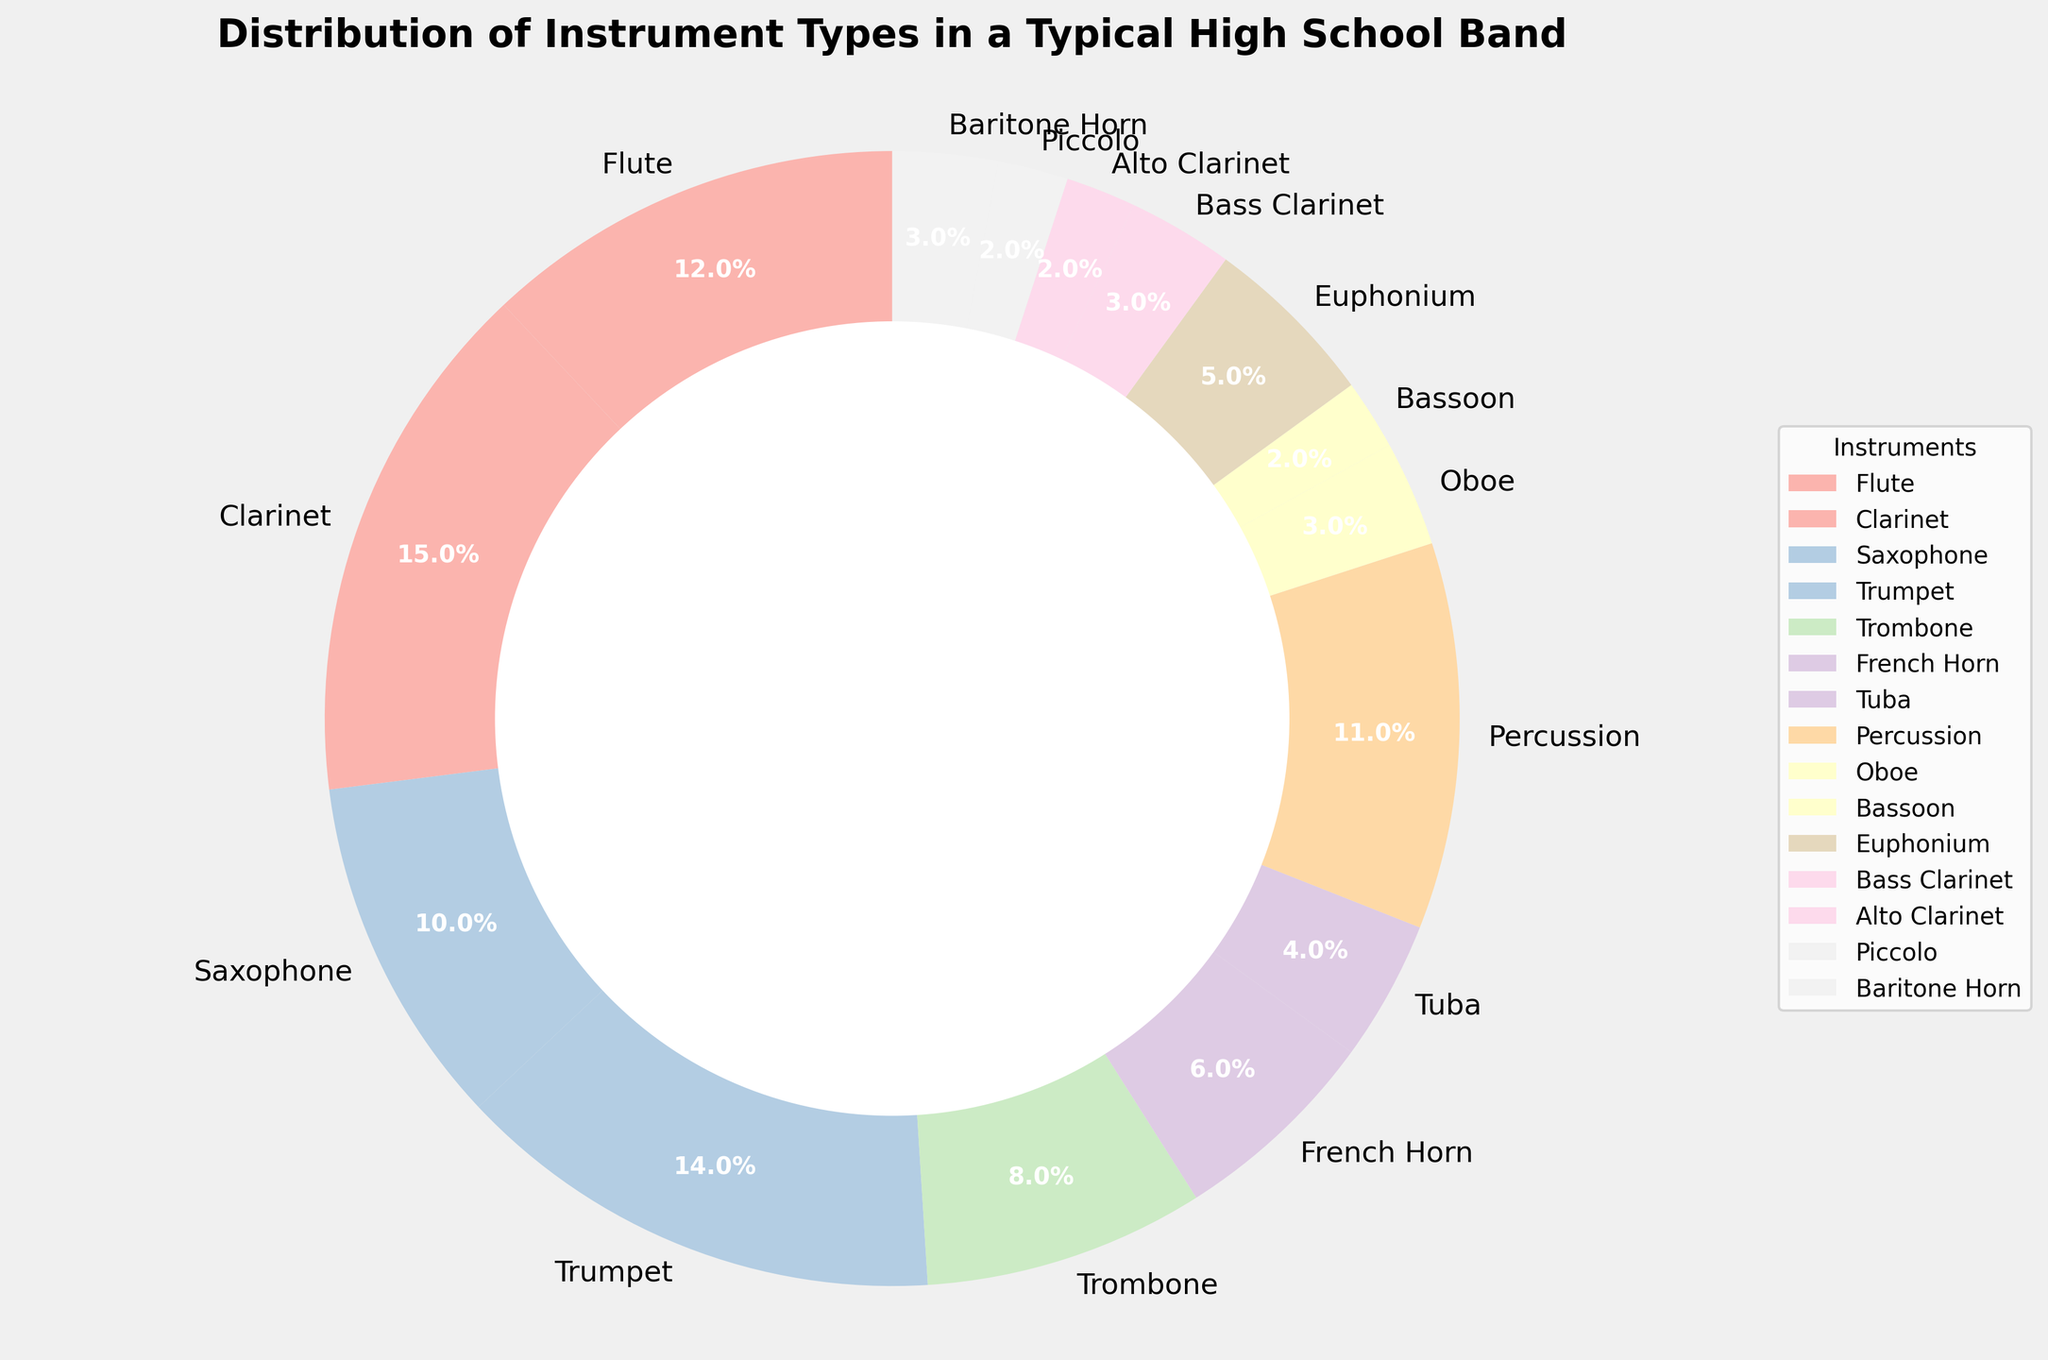What is the largest represented instrument in the band? By observing the chart, the Clarinet has the largest slice at 15%.
Answer: Clarinet What is the total percentage of woodwind instruments (Flute, Clarinet, Saxophone, Oboe, Bassoon, Bass Clarinet, Alto Clarinet, Piccolo)? Adding up the percentages: Flute (12) + Clarinet (15) + Saxophone (10) + Oboe (3) + Bassoon (2) + Bass Clarinet (3) + Alto Clarinet (2) + Piccolo (2) = 49%
Answer: 49% Which instrument group is larger: Brass or Percussion? Brass consists of Trumpet (14) + Trombone (8) + French Horn (6) + Tuba (4) + Euphonium (5) + Baritone Horn (3) = 40%. Percussion is 11%. Therefore, Brass is larger.
Answer: Brass How many instruments have a representation of 4% or less? Instruments with 4% or less are Tuba (4), Oboe (3), Bassoon (2), Bass Clarinet (3), Alto Clarinet (2), Piccolo (2), Baritone Horn (3). There are 7 such instruments in total.
Answer: 7 What is the combined percentage of the least represented instruments (Bassoon, Alto Clarinet, and Piccolo)? Adding up the percentages: Bassoon (2) + Alto Clarinet (2) + Piccolo (2) = 6%
Answer: 6% Which is more common: Flute or Trumpet? By observing the chart, Flute has a percentage of 12%, and Trumpet has a percentage of 14%. Thus, Trumpet is more common.
Answer: Trumpet What is the difference in percentage between the highest (Clarinet) and the lowest (Bassoon) represented instruments? The highest representation is Clarinet at 15% and the lowest is Bassoon at 2%. The difference is 15 - 2 = 13%.
Answer: 13% What is the second most represented instrument type? The second largest slice belongs to the Flute at 12%.
Answer: Flute Compare the combined percentage of Oboe and Bassoon to that of Euphonium. Which is larger? Oboe (3) + Bassoon (2) = 5%. Euphonium alone is also 5%. Thus, they are equal.
Answer: Equal Which instrument has a similar representation to the Percussion section? Percussion is represented by 11%. The closest instrument to this percentage is Saxophone at 10%.
Answer: Saxophone 